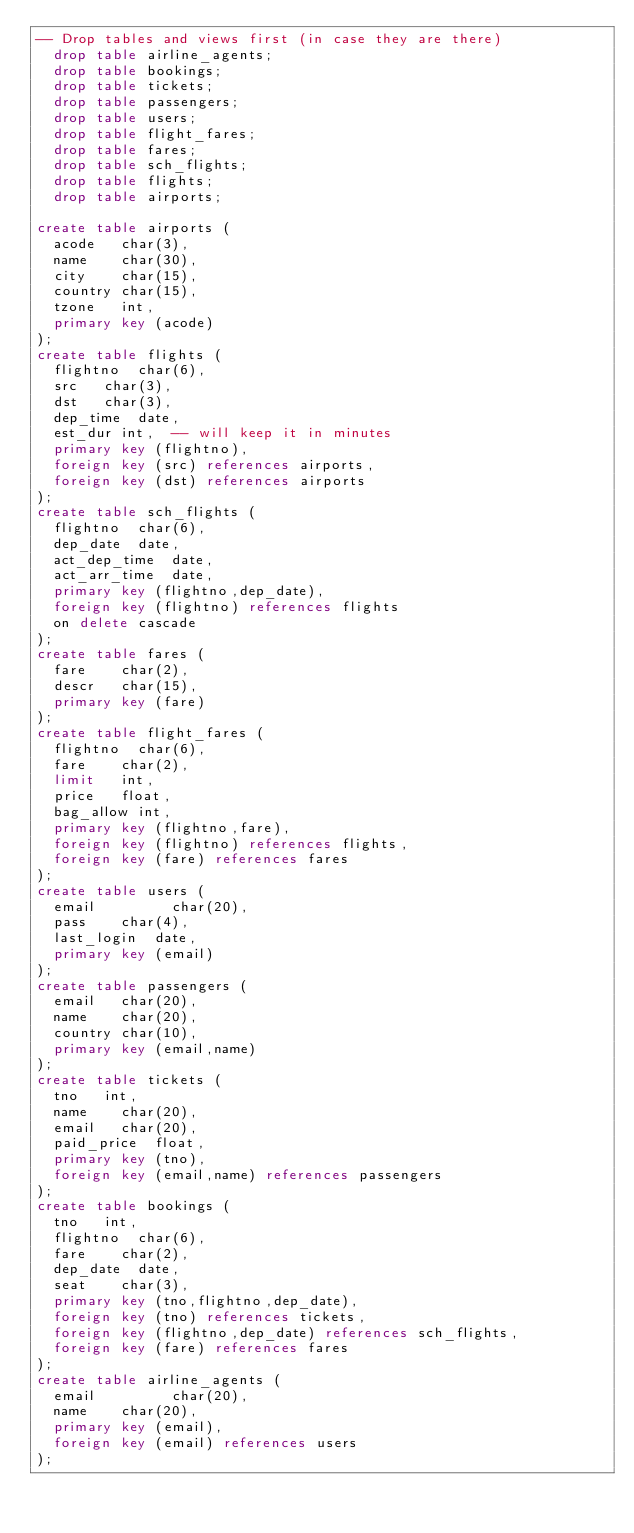Convert code to text. <code><loc_0><loc_0><loc_500><loc_500><_SQL_>-- Drop tables and views first (in case they are there)
  drop table airline_agents;
  drop table bookings;
  drop table tickets;
  drop table passengers;
  drop table users;
  drop table flight_fares;
  drop table fares;
  drop table sch_flights;
  drop table flights;
  drop table airports;

create table airports (
  acode   char(3),
  name    char(30),
  city    char(15),
  country char(15),
  tzone   int,
  primary key (acode)
);
create table flights (
  flightno  char(6),
  src   char(3),
  dst   char(3),
  dep_time  date,
  est_dur int,  -- will keep it in minutes
  primary key (flightno),
  foreign key (src) references airports,
  foreign key (dst) references airports
);
create table sch_flights (
  flightno  char(6),
  dep_date  date,
  act_dep_time  date,
  act_arr_time  date,
  primary key (flightno,dep_date),
  foreign key (flightno) references flights 
  on delete cascade
);
create table fares (
  fare    char(2),
  descr   char(15),
  primary key (fare)
);
create table flight_fares (
  flightno  char(6),
  fare    char(2),
  limit   int,
  price   float,
  bag_allow int,
  primary key (flightno,fare),
  foreign key (flightno) references flights,
  foreign key (fare) references fares
);
create table users (
  email         char(20),
  pass    char(4),
  last_login  date,
  primary key (email)
);
create table passengers (
  email   char(20),
  name    char(20),
  country char(10),
  primary key (email,name)
);
create table tickets (
  tno   int,
  name    char(20),
  email   char(20),
  paid_price  float,
  primary key (tno),
  foreign key (email,name) references passengers
);
create table bookings (
  tno   int,
  flightno  char(6),
  fare    char(2),
  dep_date  date,
  seat    char(3),
  primary key (tno,flightno,dep_date),
  foreign key (tno) references tickets,
  foreign key (flightno,dep_date) references sch_flights,
  foreign key (fare) references fares
);
create table airline_agents (
  email         char(20),
  name    char(20),
  primary key (email),
  foreign key (email) references users
);</code> 